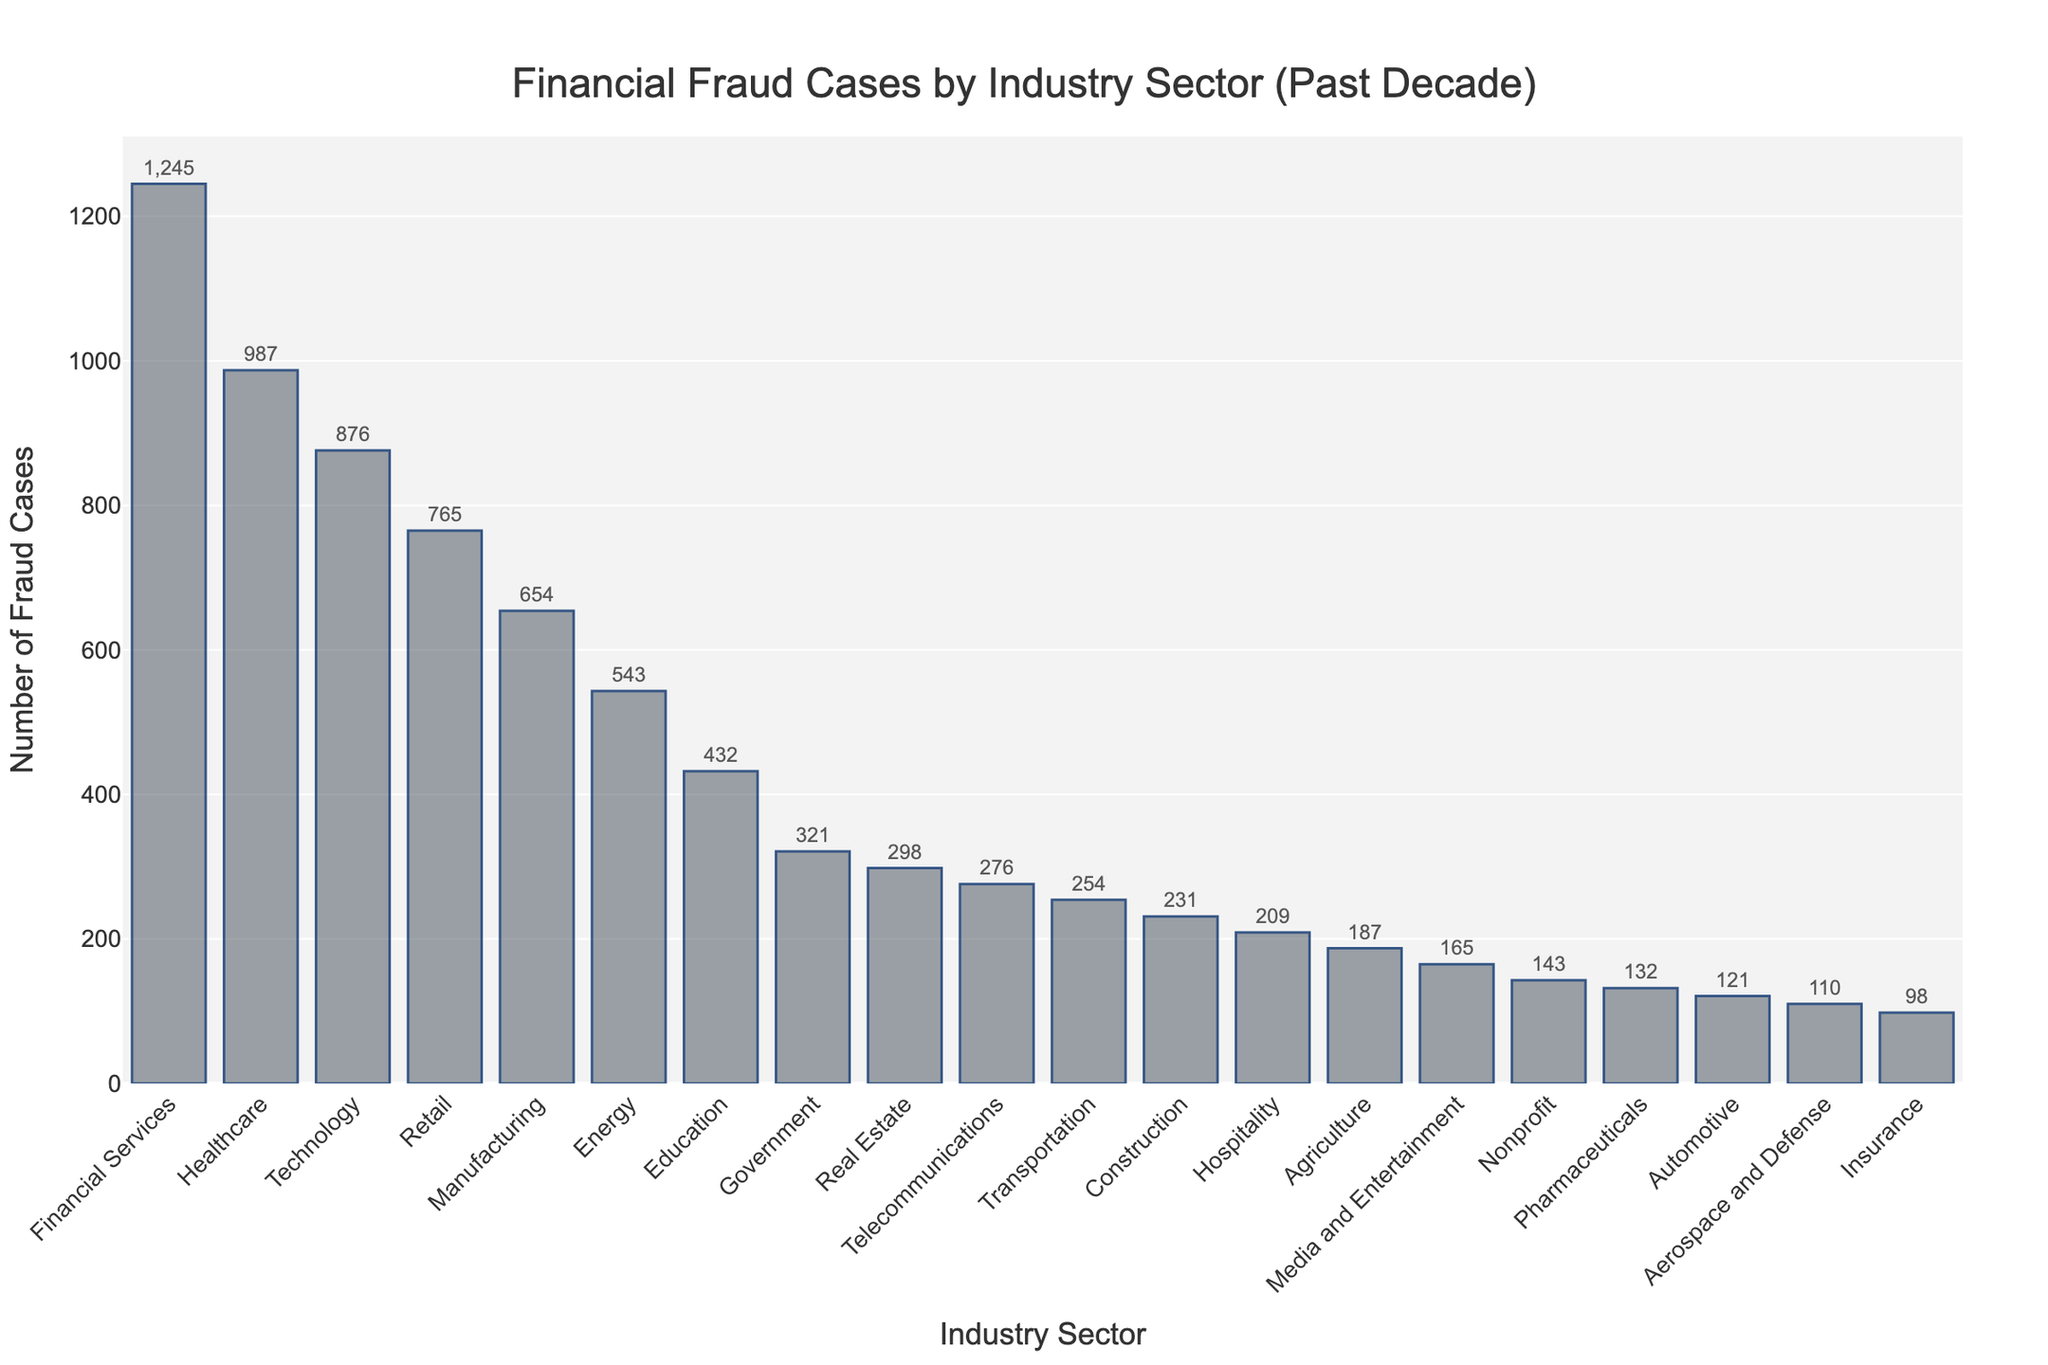What's the total number of fraud cases across the top 3 industry sectors? First, identify the top 3 industry sectors by the number of fraud cases: Financial Services (1245), Healthcare (987), and Technology (876). Sum these values: 1245 + 987 + 876 = 3108.
Answer: 3108 How many more fraud cases did Financial Services have compared to Pharmaceuticals? Determine the number of fraud cases in Financial Services (1245) and Pharmaceuticals (132). Subtract the number in Pharmaceuticals from Financial Services: 1245 - 132 = 1113.
Answer: 1113 Which industry sector has the least number of fraud cases? Identify the sector with the smallest number of fraud cases by examining the heights of the bars. The shortest bar corresponds to Insurance with 98 fraud cases.
Answer: Insurance Is the number of fraud cases in Healthcare greater than the combined total of Education and Real Estate? Identify the number of fraud cases in Healthcare (987), Education (432), and Real Estate (298). Sum the values for Education and Real Estate: 432 + 298 = 730. Compare Healthcare (987) to this sum: 987 > 730, so yes.
Answer: Yes Which industries have more fraud cases than Retail but fewer than Financial Services? Identify the number of fraud cases in Retail (765) and Financial Services (1245). Find sectors in between these values: Healthcare (987) and Technology (876).
Answer: Healthcare, Technology How many sectors have more than 500 fraud cases? Count the number of bars representing industries with more than 500 fraud cases: Financial Services, Healthcare, Technology, Retail, Manufacturing, and Energy. There are 6 such sectors.
Answer: 6 What is the difference between the number of fraud cases in Government and Real Estate? Identify the number of fraud cases in Government (321) and Real Estate (298). Subtract Real Estate from Government: 321 - 298 = 23.
Answer: 23 Does the Transport sector have fewer fraud cases than the Telecommunications sector? Identify the number of fraud cases in the Transportation (254) and Telecommunications (276) sectors. Compare the values: 254 < 276, so yes.
Answer: Yes What fraction of the total fraud cases are in the Nonprofit sector? Identify the number of fraud cases in the Nonprofit sector (143). Sum the total number of fraud cases across all sectors: 8604. Calculate the fraction: 143/8604.
Answer: Approximately 1/60 